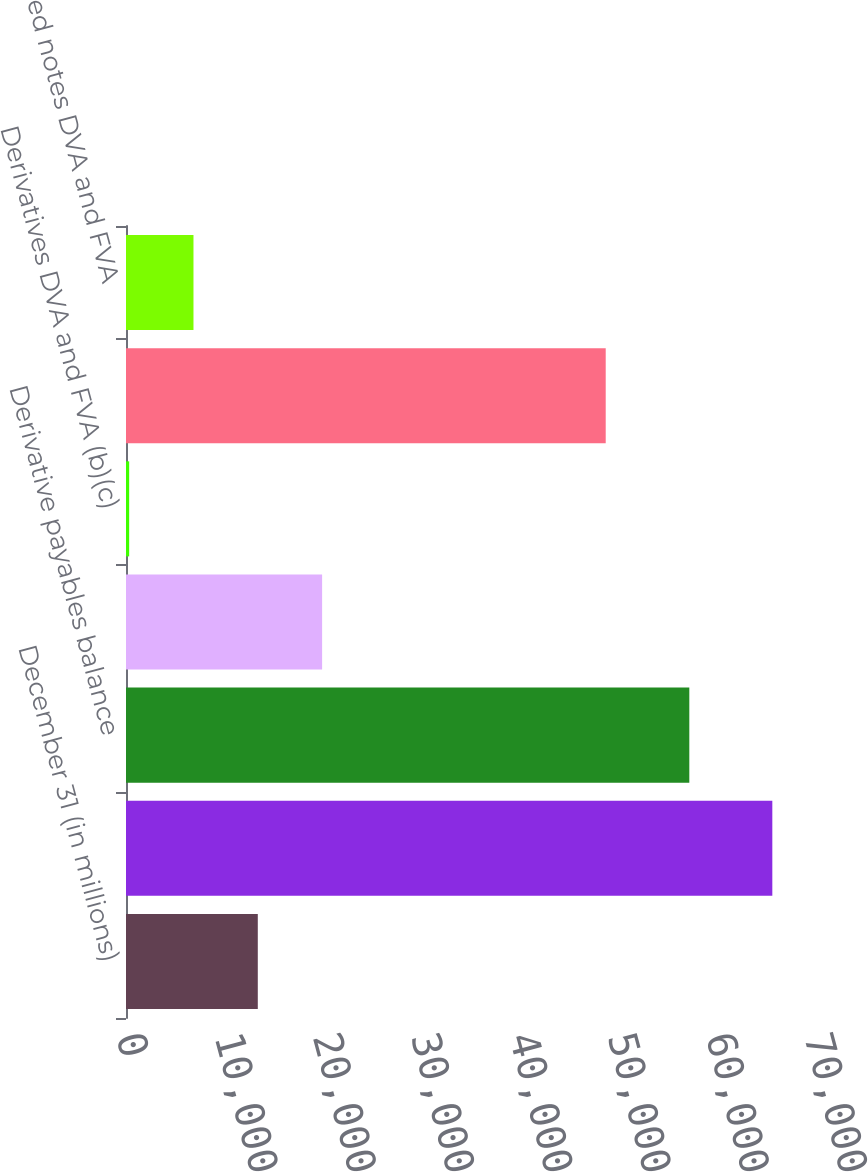Convert chart. <chart><loc_0><loc_0><loc_500><loc_500><bar_chart><fcel>December 31 (in millions)<fcel>Derivative receivables balance<fcel>Derivative payables balance<fcel>Derivatives CVA (b)<fcel>Derivatives DVA and FVA (b)(c)<fcel>Structured notes balance<fcel>Structured notes DVA and FVA<nl><fcel>13409.4<fcel>65759<fcel>57314<fcel>19953.1<fcel>322<fcel>48808<fcel>6865.7<nl></chart> 